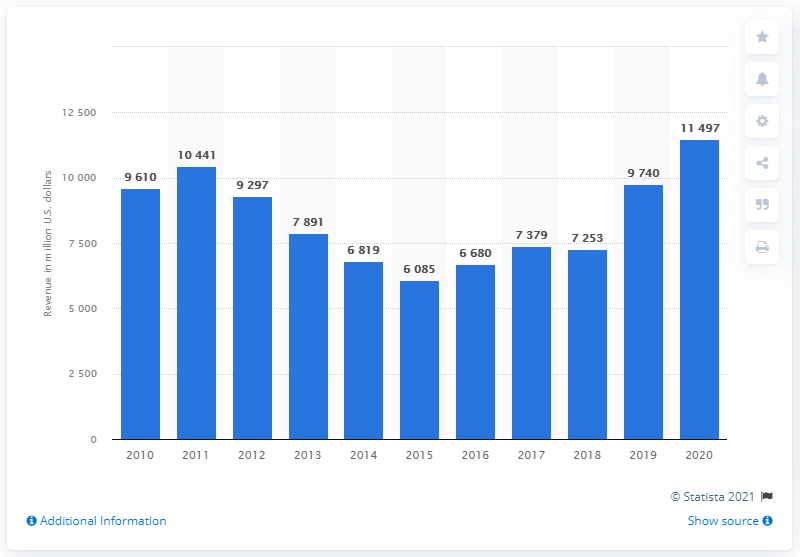Give some essential details in this illustration. In 2020, Newmont generated $11,497 in revenue. 